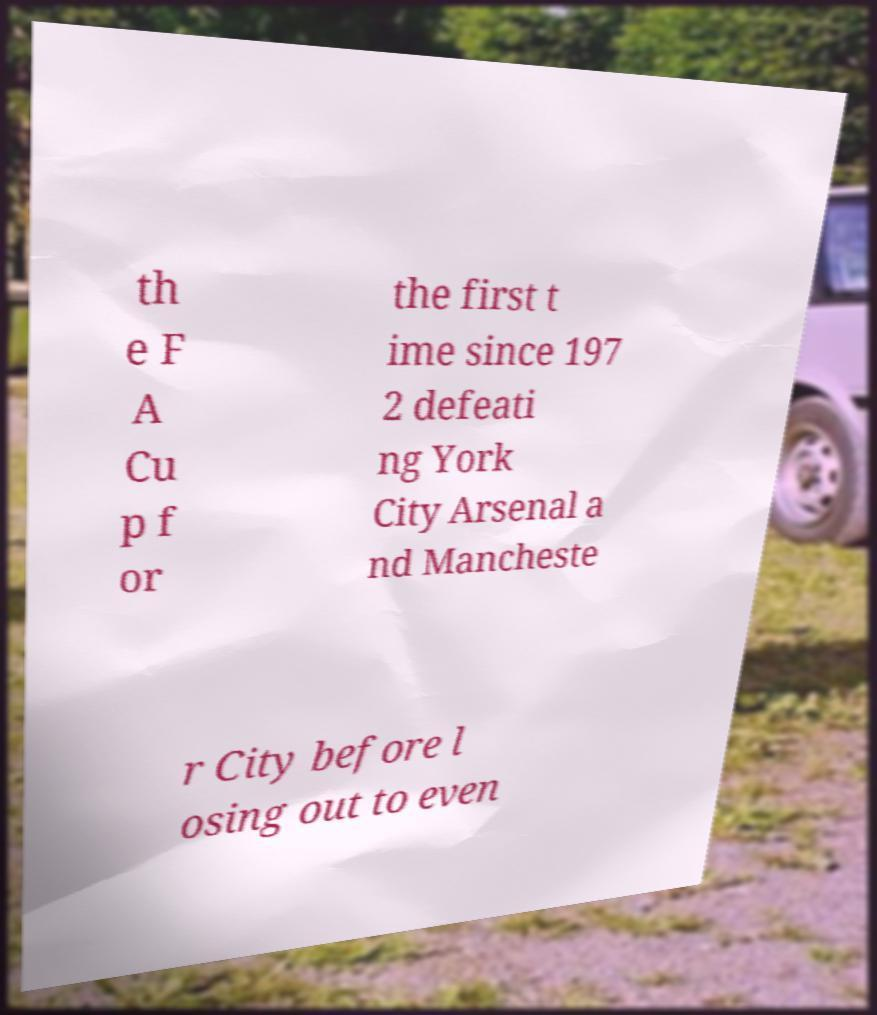I need the written content from this picture converted into text. Can you do that? th e F A Cu p f or the first t ime since 197 2 defeati ng York City Arsenal a nd Mancheste r City before l osing out to even 